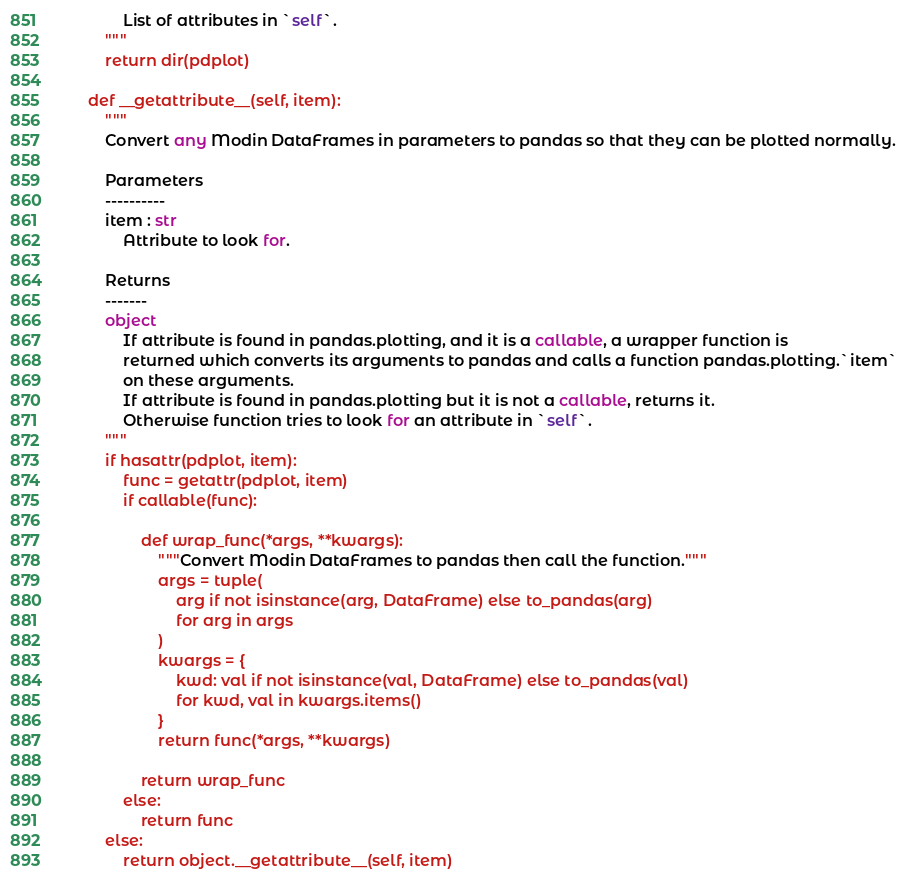Convert code to text. <code><loc_0><loc_0><loc_500><loc_500><_Python_>            List of attributes in `self`.
        """
        return dir(pdplot)

    def __getattribute__(self, item):
        """
        Convert any Modin DataFrames in parameters to pandas so that they can be plotted normally.

        Parameters
        ----------
        item : str
            Attribute to look for.

        Returns
        -------
        object
            If attribute is found in pandas.plotting, and it is a callable, a wrapper function is
            returned which converts its arguments to pandas and calls a function pandas.plotting.`item`
            on these arguments.
            If attribute is found in pandas.plotting but it is not a callable, returns it.
            Otherwise function tries to look for an attribute in `self`.
        """
        if hasattr(pdplot, item):
            func = getattr(pdplot, item)
            if callable(func):

                def wrap_func(*args, **kwargs):
                    """Convert Modin DataFrames to pandas then call the function."""
                    args = tuple(
                        arg if not isinstance(arg, DataFrame) else to_pandas(arg)
                        for arg in args
                    )
                    kwargs = {
                        kwd: val if not isinstance(val, DataFrame) else to_pandas(val)
                        for kwd, val in kwargs.items()
                    }
                    return func(*args, **kwargs)

                return wrap_func
            else:
                return func
        else:
            return object.__getattribute__(self, item)
</code> 